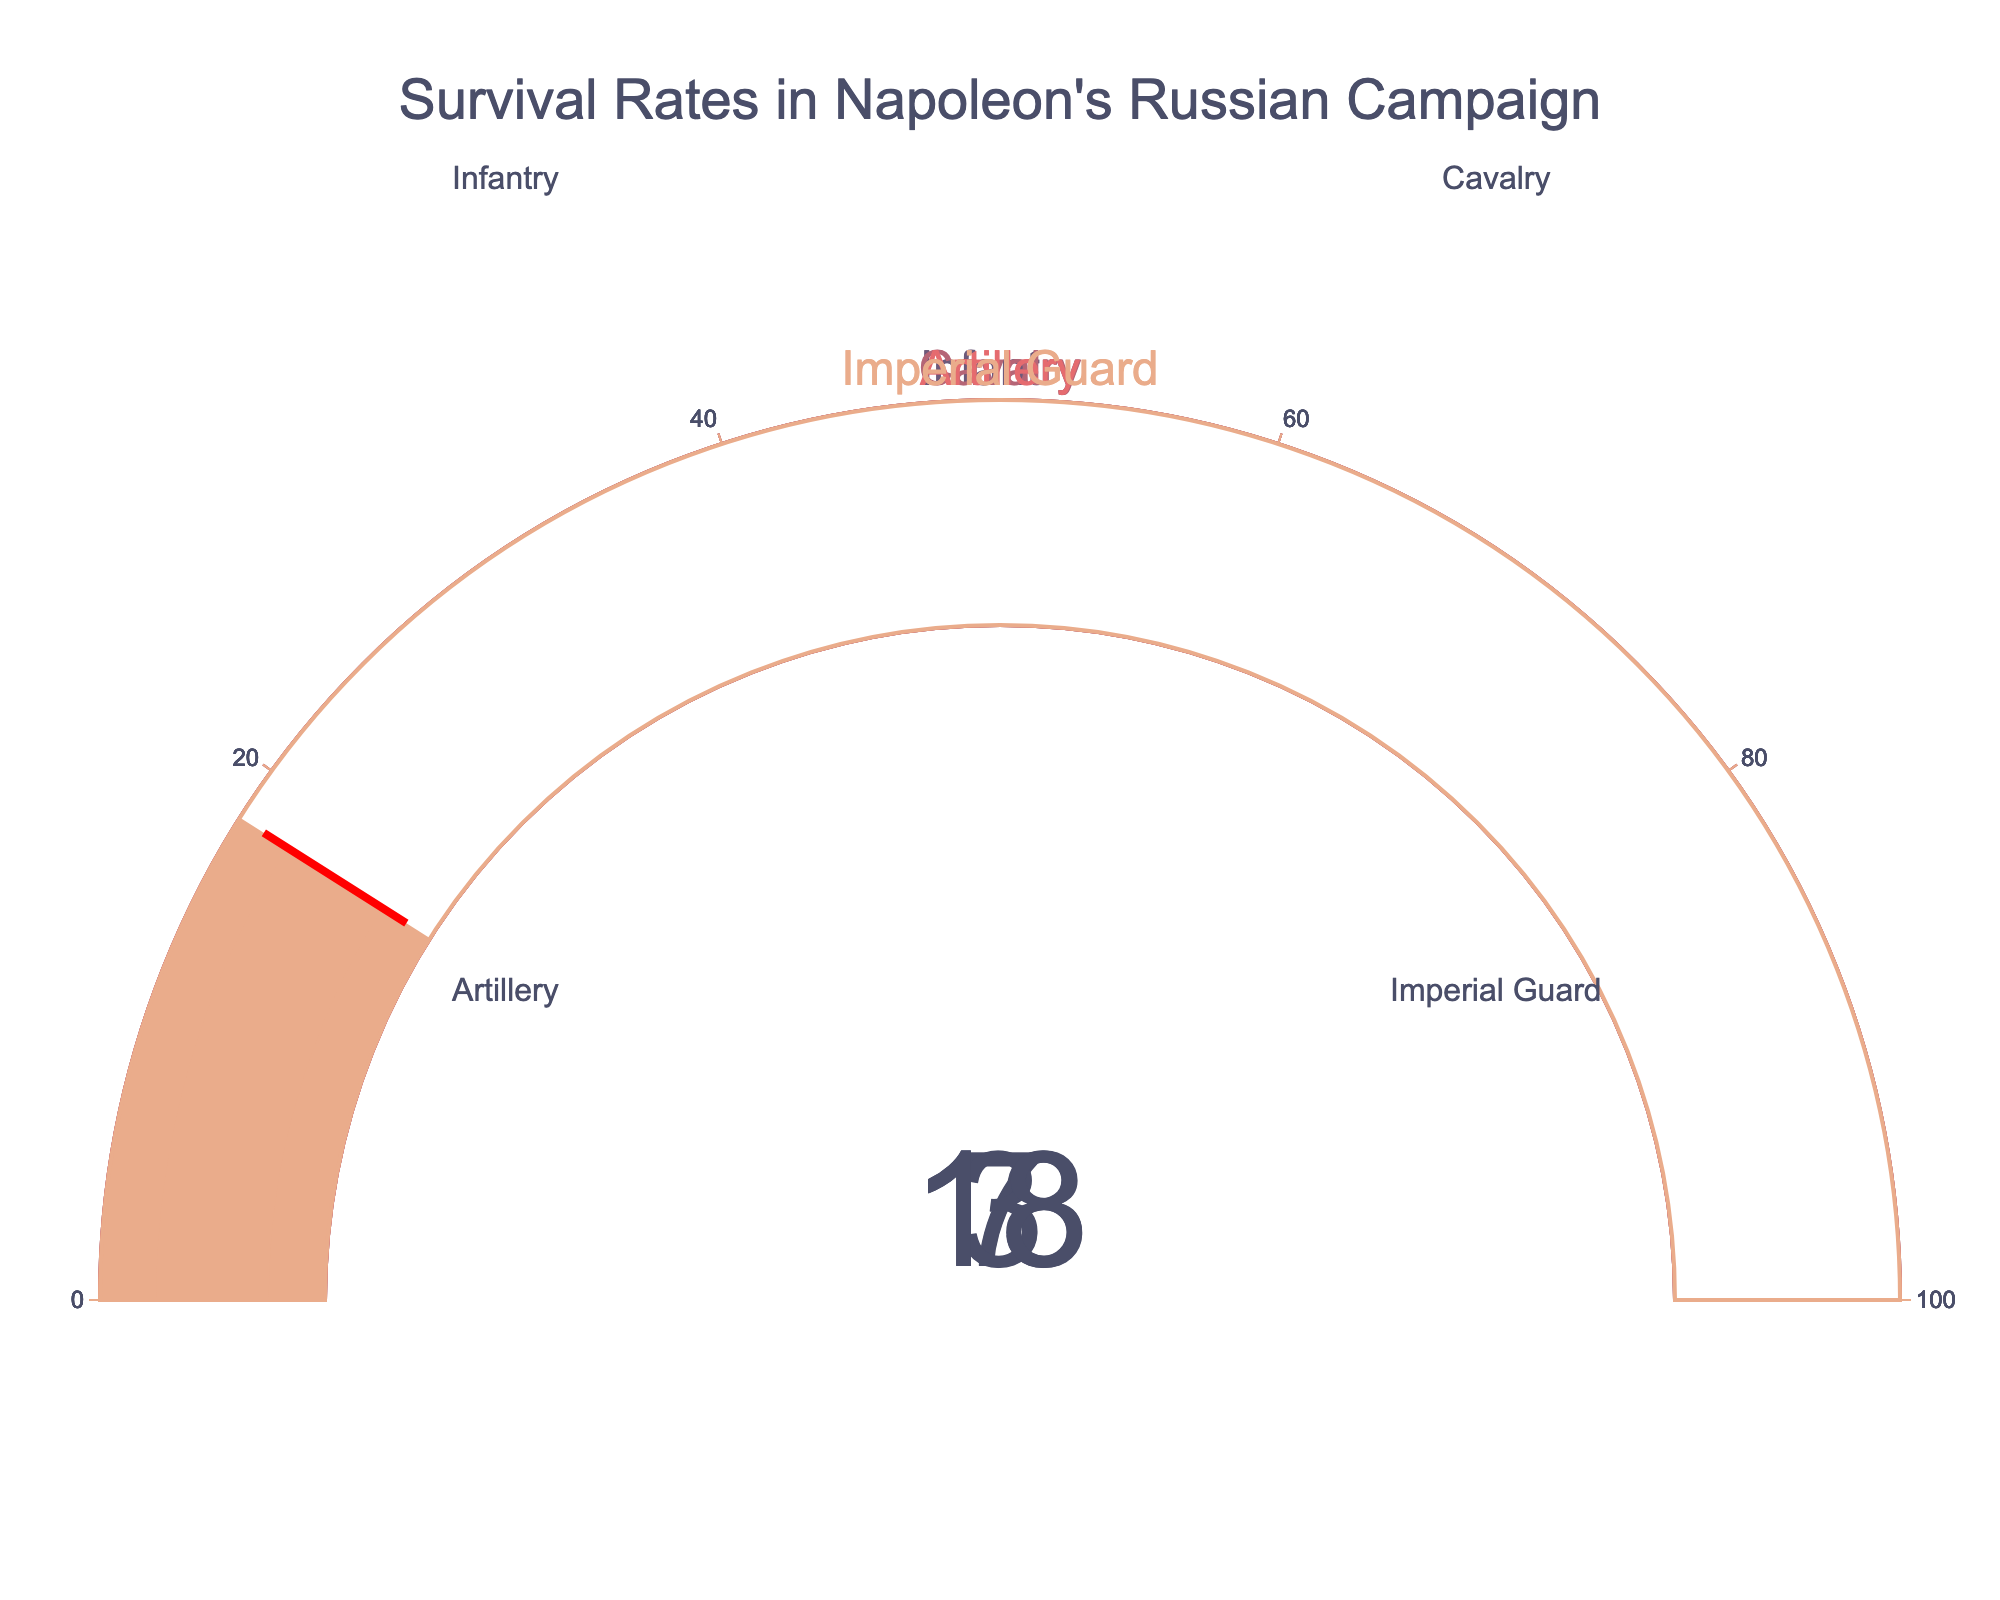What's the title of the chart? The chart title is displayed at the top of the figure. It reads "Survival Rates in Napoleon's Russian Campaign".
Answer: Survival Rates in Napoleon's Russian Campaign Which category has the highest survival percentage? By examining the gauges, the Imperial Guard has the highest percentage at 18.
Answer: Imperial Guard What is the difference in survival percentage between the Cavalry and the Artillery? The Cavalry has a survival percentage of 7 and the Artillery has 3. Subtracting 3 from 7 gives the difference.
Answer: 4 What are the survival percentages for the Infantry and the Artillery combined? The Infantry has a survival percentage of 13 and the Artillery has 3. Adding these values together gives the combined percentage.
Answer: 16 Are any of the categories above 20% survival? Observing the gauges, none of the categories have a survival percentage above 20%.
Answer: No Which two categories have the smallest survival rates? The gauges indicate that the Artillery and the Cavalry have the smallest survival rates at 3% and 7% respectively.
Answer: Artillery and Cavalry What’s the average survival percentage across all categories? Add the percentages for each category (13+7+3+18) which sums to 41. Divide this by the number of categories, which is 4.
Answer: 10.25 Which category has exactly twice the survival percentage of the Artillery? The Artillery’s percentage is 3. Doubling that gives 6. The Cavalry has a percentage close to this (7 is the closest but not exactly twice).
Answer: None What is the combined survival percentage of the highest and lowest categories? The highest percentage is for the Imperial Guard at 18, and the lowest is for the Artillery at 3. Their combined percentage is 18+3.
Answer: 21 